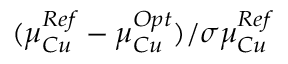<formula> <loc_0><loc_0><loc_500><loc_500>( \mu _ { C u } ^ { R e f } - \mu _ { C u } ^ { O p t } ) / \sigma \mu _ { C u } ^ { R e f }</formula> 